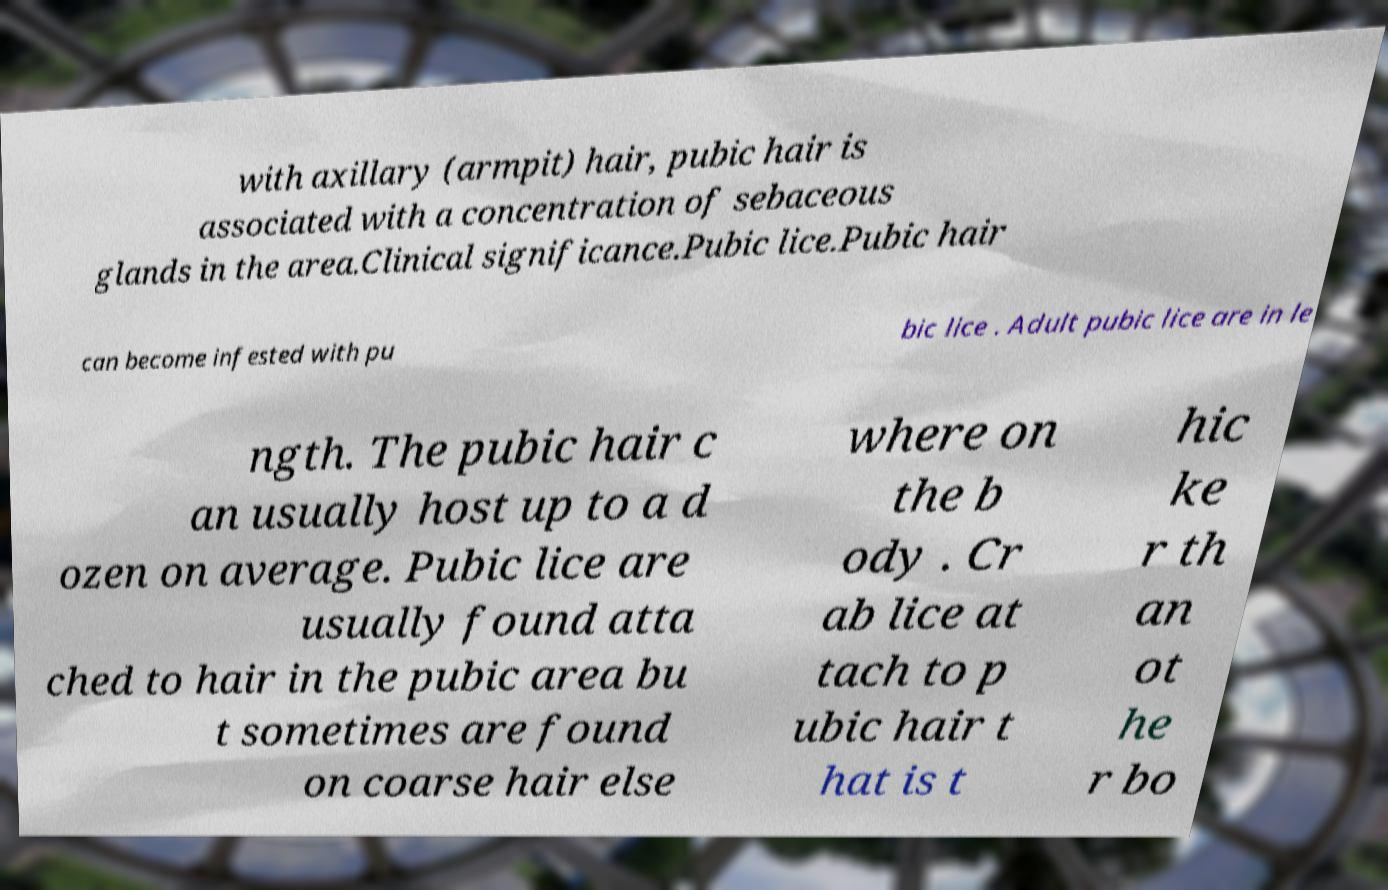Please identify and transcribe the text found in this image. with axillary (armpit) hair, pubic hair is associated with a concentration of sebaceous glands in the area.Clinical significance.Pubic lice.Pubic hair can become infested with pu bic lice . Adult pubic lice are in le ngth. The pubic hair c an usually host up to a d ozen on average. Pubic lice are usually found atta ched to hair in the pubic area bu t sometimes are found on coarse hair else where on the b ody . Cr ab lice at tach to p ubic hair t hat is t hic ke r th an ot he r bo 